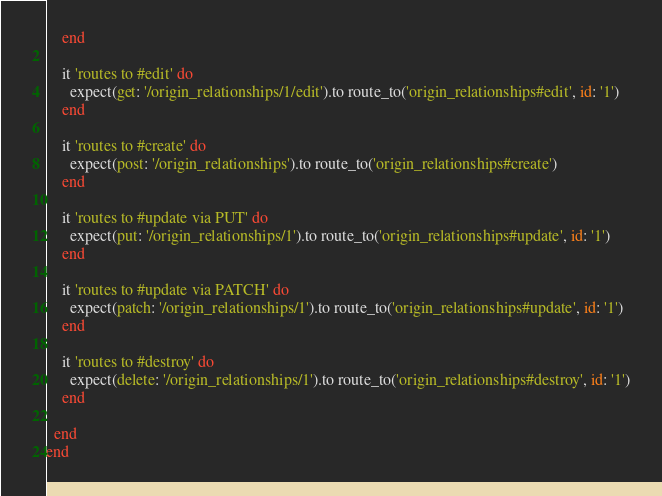Convert code to text. <code><loc_0><loc_0><loc_500><loc_500><_Ruby_>    end

    it 'routes to #edit' do
      expect(get: '/origin_relationships/1/edit').to route_to('origin_relationships#edit', id: '1')
    end

    it 'routes to #create' do
      expect(post: '/origin_relationships').to route_to('origin_relationships#create')
    end

    it 'routes to #update via PUT' do
      expect(put: '/origin_relationships/1').to route_to('origin_relationships#update', id: '1')
    end

    it 'routes to #update via PATCH' do
      expect(patch: '/origin_relationships/1').to route_to('origin_relationships#update', id: '1')
    end

    it 'routes to #destroy' do
      expect(delete: '/origin_relationships/1').to route_to('origin_relationships#destroy', id: '1')
    end

  end
end
</code> 